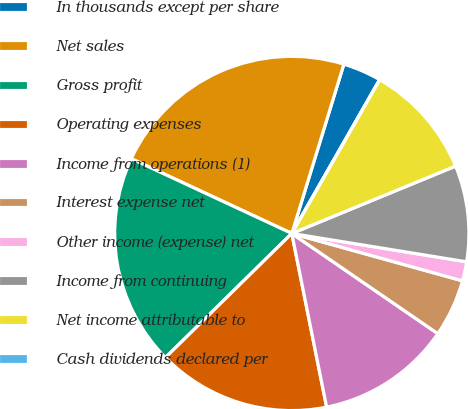<chart> <loc_0><loc_0><loc_500><loc_500><pie_chart><fcel>In thousands except per share<fcel>Net sales<fcel>Gross profit<fcel>Operating expenses<fcel>Income from operations (1)<fcel>Interest expense net<fcel>Other income (expense) net<fcel>Income from continuing<fcel>Net income attributable to<fcel>Cash dividends declared per<nl><fcel>3.51%<fcel>22.81%<fcel>19.3%<fcel>15.79%<fcel>12.28%<fcel>5.26%<fcel>1.75%<fcel>8.77%<fcel>10.53%<fcel>0.0%<nl></chart> 